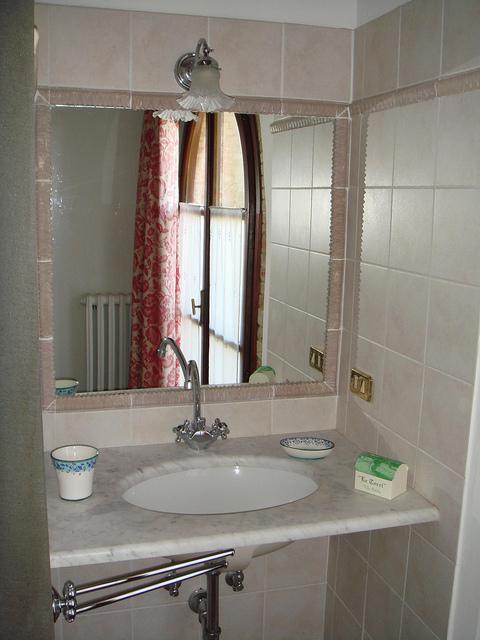What room of the house is shown?
Write a very short answer. Bathroom. How many mirror are in this picture?
Be succinct. 1. What color are the tiles?
Write a very short answer. White. What is the sink made out of?
Give a very brief answer. Porcelain. 